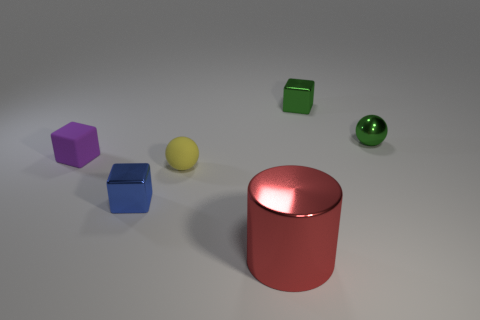What color is the small shiny thing that is both left of the tiny green metallic sphere and on the right side of the blue object?
Offer a very short reply. Green. What material is the block right of the blue thing?
Ensure brevity in your answer.  Metal. Is there another red metallic thing of the same shape as the large red object?
Your answer should be compact. No. What number of other things are the same shape as the blue metallic object?
Your response must be concise. 2. There is a big metallic object; does it have the same shape as the metallic object on the left side of the big red metal object?
Offer a very short reply. No. Is there any other thing that is the same material as the green block?
Provide a short and direct response. Yes. What material is the tiny green object that is the same shape as the blue thing?
Give a very brief answer. Metal. How many large things are blocks or brown metallic cubes?
Keep it short and to the point. 0. Are there fewer tiny green blocks left of the tiny yellow sphere than small blue cubes that are behind the purple rubber block?
Your answer should be compact. No. What number of objects are either shiny blocks or shiny balls?
Keep it short and to the point. 3. 